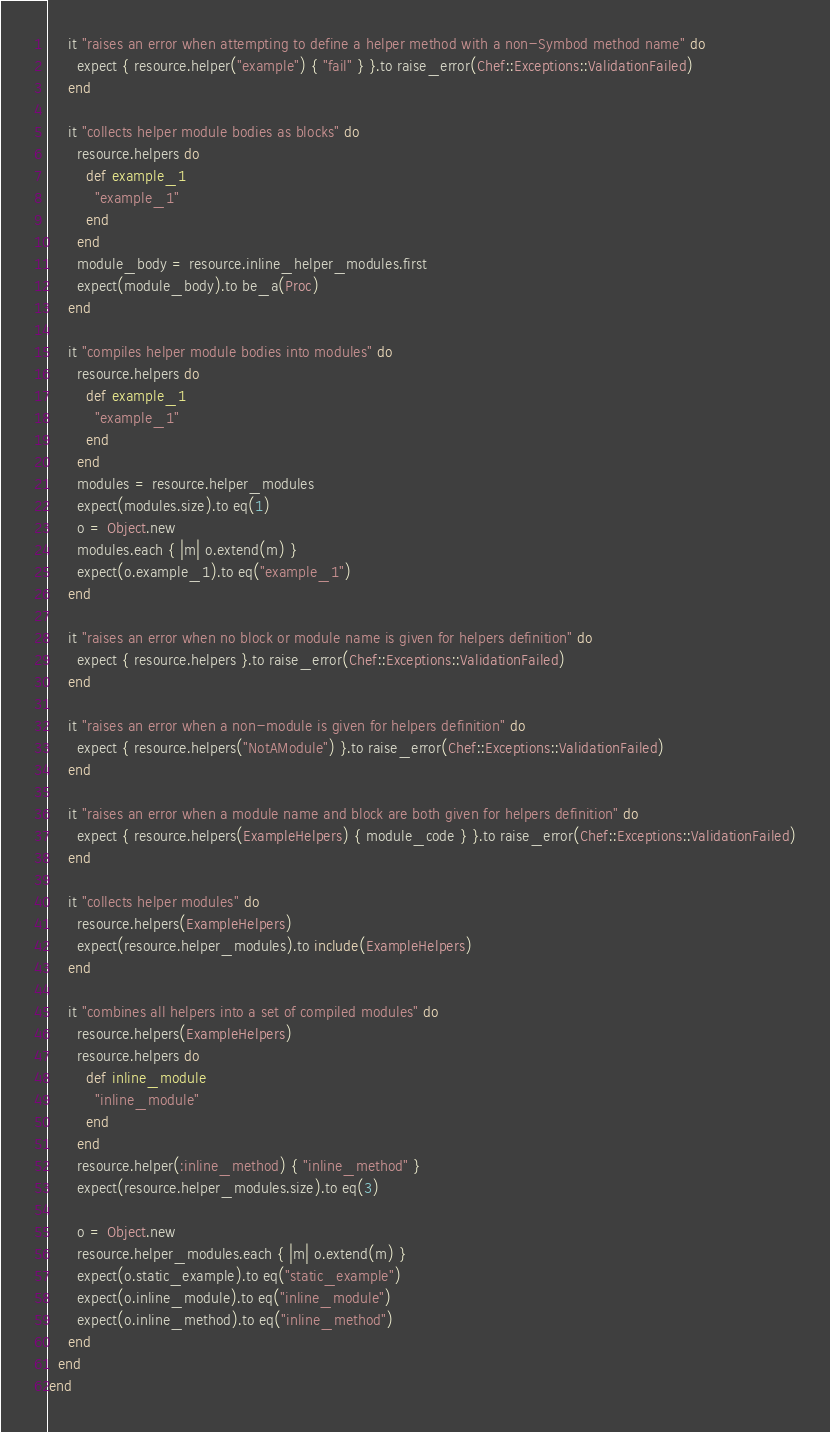Convert code to text. <code><loc_0><loc_0><loc_500><loc_500><_Ruby_>    it "raises an error when attempting to define a helper method with a non-Symbod method name" do
      expect { resource.helper("example") { "fail" } }.to raise_error(Chef::Exceptions::ValidationFailed)
    end

    it "collects helper module bodies as blocks" do
      resource.helpers do
        def example_1
          "example_1"
        end
      end
      module_body = resource.inline_helper_modules.first
      expect(module_body).to be_a(Proc)
    end

    it "compiles helper module bodies into modules" do
      resource.helpers do
        def example_1
          "example_1"
        end
      end
      modules = resource.helper_modules
      expect(modules.size).to eq(1)
      o = Object.new
      modules.each { |m| o.extend(m) }
      expect(o.example_1).to eq("example_1")
    end

    it "raises an error when no block or module name is given for helpers definition" do
      expect { resource.helpers }.to raise_error(Chef::Exceptions::ValidationFailed)
    end

    it "raises an error when a non-module is given for helpers definition" do
      expect { resource.helpers("NotAModule") }.to raise_error(Chef::Exceptions::ValidationFailed)
    end

    it "raises an error when a module name and block are both given for helpers definition" do
      expect { resource.helpers(ExampleHelpers) { module_code } }.to raise_error(Chef::Exceptions::ValidationFailed)
    end

    it "collects helper modules" do
      resource.helpers(ExampleHelpers)
      expect(resource.helper_modules).to include(ExampleHelpers)
    end

    it "combines all helpers into a set of compiled modules" do
      resource.helpers(ExampleHelpers)
      resource.helpers do
        def inline_module
          "inline_module"
        end
      end
      resource.helper(:inline_method) { "inline_method" }
      expect(resource.helper_modules.size).to eq(3)

      o = Object.new
      resource.helper_modules.each { |m| o.extend(m) }
      expect(o.static_example).to eq("static_example")
      expect(o.inline_module).to eq("inline_module")
      expect(o.inline_method).to eq("inline_method")
    end
  end
end
</code> 